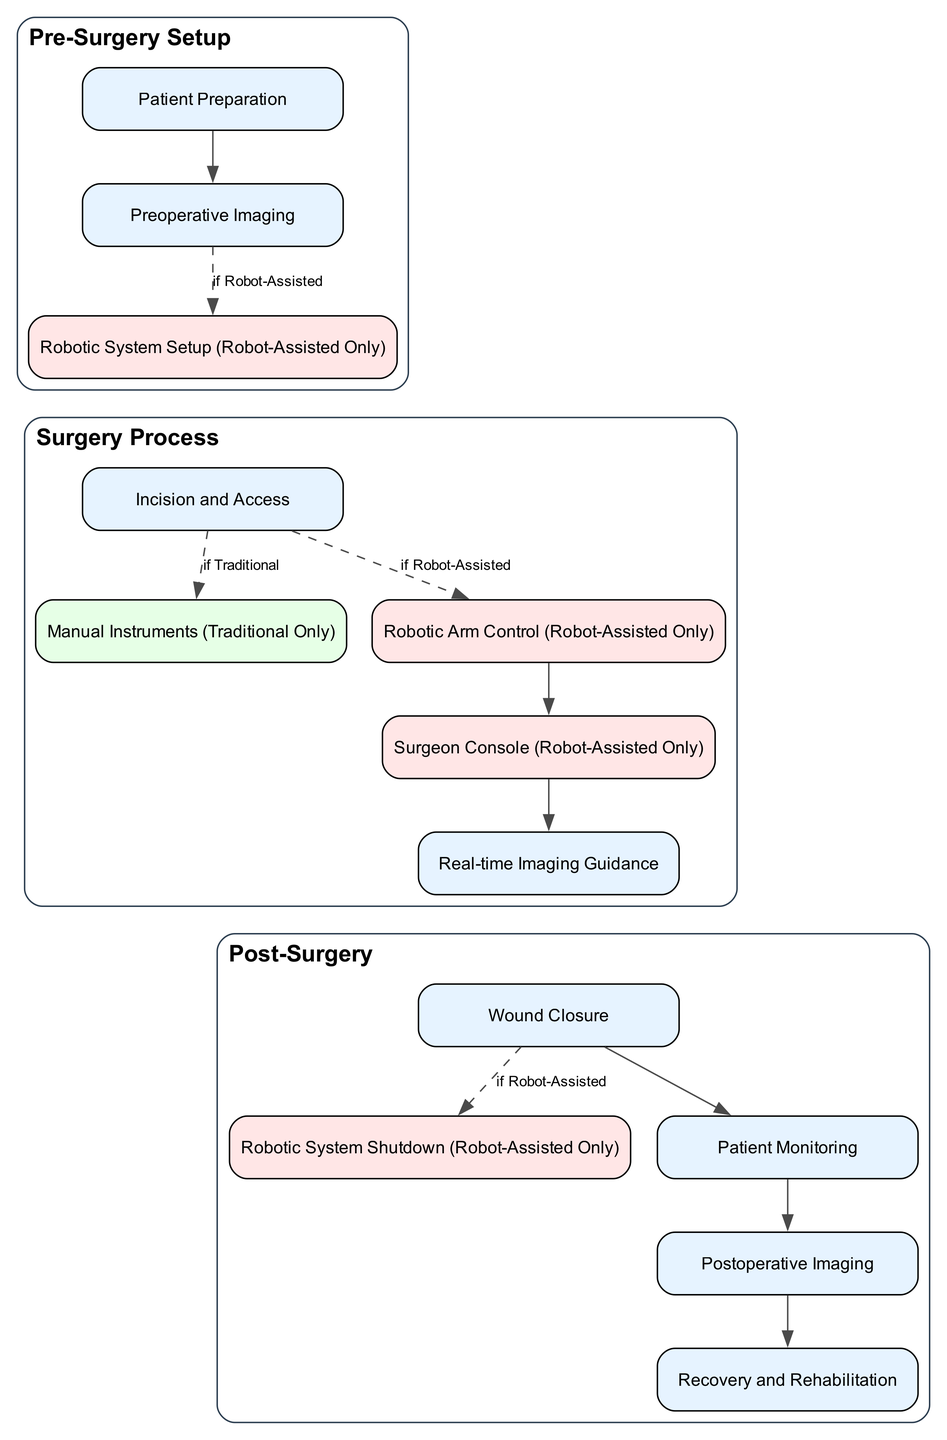What are the three nodes in the 'Pre-Surgery Setup' section? The 'Pre-Surgery Setup' section contains three nodes: Patient Preparation, Preoperative Imaging, and Robotic System Setup (Robot-Assisted Only). These nodes are listed under the title of this section in the diagram.
Answer: Patient Preparation, Preoperative Imaging, Robotic System Setup (Robot-Assisted Only) Which step comes after 'Robotic Arm Control (Robot-Assisted Only)'? After 'Robotic Arm Control (Robot-Assisted Only)', the next step is 'Surgeon Console (Robot-Assisted Only)'. The edge connecting these two nodes shows the flow from one to the other.
Answer: Surgeon Console (Robot-Assisted Only) What is the label of the edge connecting 'Preoperative Imaging' to 'Robotic System Setup (Robot-Assisted Only)'? The edge connecting 'Preoperative Imaging' to 'Robotic System Setup (Robot-Assisted Only)' is labeled "if Robot-Assisted". This conditional label indicates when the robotic system setup step occurs based on the type of surgery being performed.
Answer: if Robot-Assisted How many nodes are there in the 'Post-Surgery' section? The 'Post-Surgery' section contains five nodes: Wound Closure, Robotic System Shutdown (Robot-Assisted Only), Patient Monitoring, Postoperative Imaging, and Recovery and Rehabilitation. The count can be verified by counting each listed node under this section title.
Answer: 5 What is the final step after 'Postoperative Imaging'? The final step after 'Postoperative Imaging' is 'Recovery and Rehabilitation'. The connecting edge indicates the sequence of steps leading to the next phase of patient care following imaging.
Answer: Recovery and Rehabilitation What happens if the surgery is traditional after 'Incision and Access'? If the surgery is traditional after 'Incision and Access', the subsequent step is 'Manual Instruments (Traditional Only)'. This is highlighted by the edge labeled "if Traditional" from 'Incision and Access' to 'Manual Instruments (Traditional Only)'.
Answer: Manual Instruments (Traditional Only) What are the two actions that occur after 'Wound Closure' in robot-assisted surgery? After 'Wound Closure' in robot-assisted surgery, the two actions that occur are 'Robotic System Shutdown (Robot-Assisted Only)' and 'Patient Monitoring'. The edge indicates a sequential flow from wound closure to these two post-surgical activities.
Answer: Robotic System Shutdown (Robot-Assisted Only), Patient Monitoring How does 'Robotic System Setup (Robot-Assisted Only)' connect to the surgery process? 'Robotic System Setup (Robot-Assisted Only)' connects to the surgery process by leading directly to 'Incision and Access'. This connection suggests that after the robotic system is set up, the surgery process begins with the incision.
Answer: It leads directly to 'Incision and Access' 